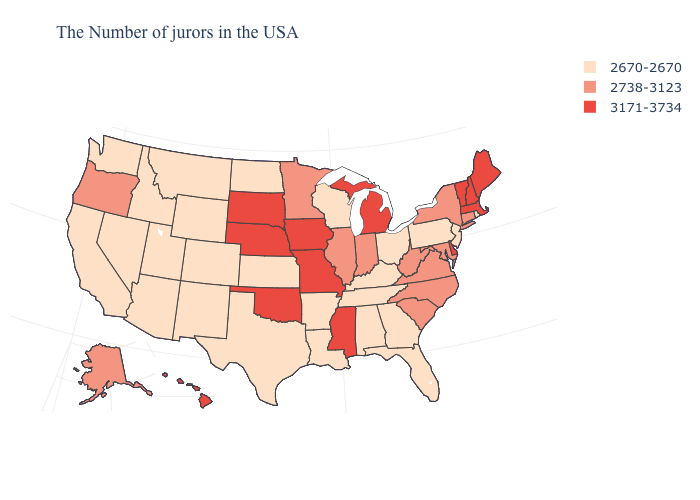Does Louisiana have a higher value than Connecticut?
Answer briefly. No. What is the value of Oklahoma?
Write a very short answer. 3171-3734. Name the states that have a value in the range 2670-2670?
Give a very brief answer. Rhode Island, New Jersey, Pennsylvania, Ohio, Florida, Georgia, Kentucky, Alabama, Tennessee, Wisconsin, Louisiana, Arkansas, Kansas, Texas, North Dakota, Wyoming, Colorado, New Mexico, Utah, Montana, Arizona, Idaho, Nevada, California, Washington. What is the lowest value in the USA?
Concise answer only. 2670-2670. Does Ohio have a lower value than Washington?
Quick response, please. No. What is the value of Alabama?
Short answer required. 2670-2670. Among the states that border Maryland , does West Virginia have the highest value?
Keep it brief. No. Does the first symbol in the legend represent the smallest category?
Keep it brief. Yes. Name the states that have a value in the range 2670-2670?
Give a very brief answer. Rhode Island, New Jersey, Pennsylvania, Ohio, Florida, Georgia, Kentucky, Alabama, Tennessee, Wisconsin, Louisiana, Arkansas, Kansas, Texas, North Dakota, Wyoming, Colorado, New Mexico, Utah, Montana, Arizona, Idaho, Nevada, California, Washington. Name the states that have a value in the range 3171-3734?
Concise answer only. Maine, Massachusetts, New Hampshire, Vermont, Delaware, Michigan, Mississippi, Missouri, Iowa, Nebraska, Oklahoma, South Dakota, Hawaii. Does Colorado have the highest value in the USA?
Write a very short answer. No. Does Iowa have the highest value in the MidWest?
Concise answer only. Yes. Does the first symbol in the legend represent the smallest category?
Keep it brief. Yes. Name the states that have a value in the range 2738-3123?
Answer briefly. Connecticut, New York, Maryland, Virginia, North Carolina, South Carolina, West Virginia, Indiana, Illinois, Minnesota, Oregon, Alaska. What is the value of Indiana?
Write a very short answer. 2738-3123. 